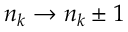<formula> <loc_0><loc_0><loc_500><loc_500>{ { n } _ { k } } \to { { n } _ { k } } \pm 1</formula> 